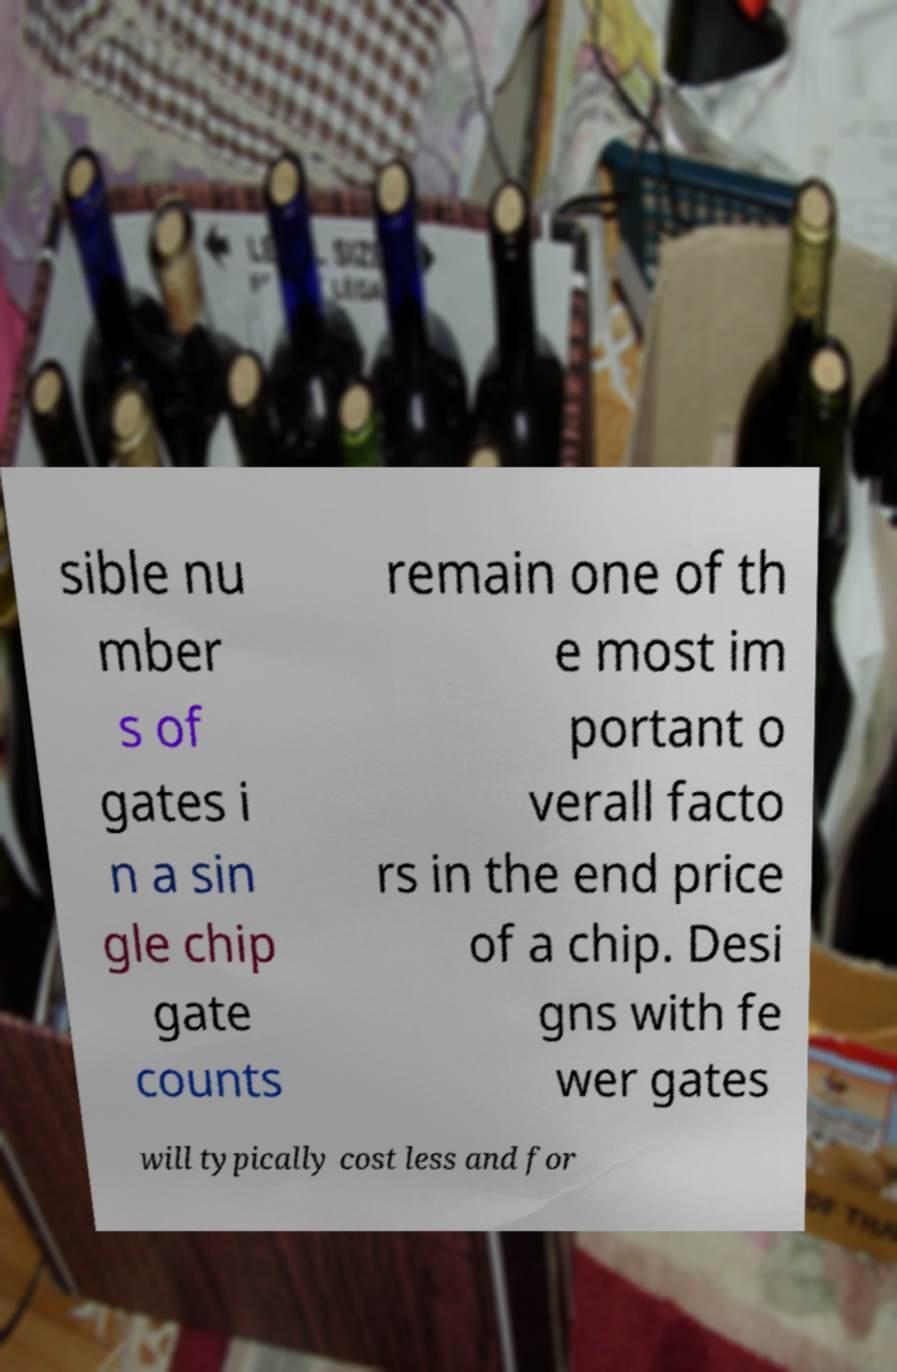There's text embedded in this image that I need extracted. Can you transcribe it verbatim? sible nu mber s of gates i n a sin gle chip gate counts remain one of th e most im portant o verall facto rs in the end price of a chip. Desi gns with fe wer gates will typically cost less and for 